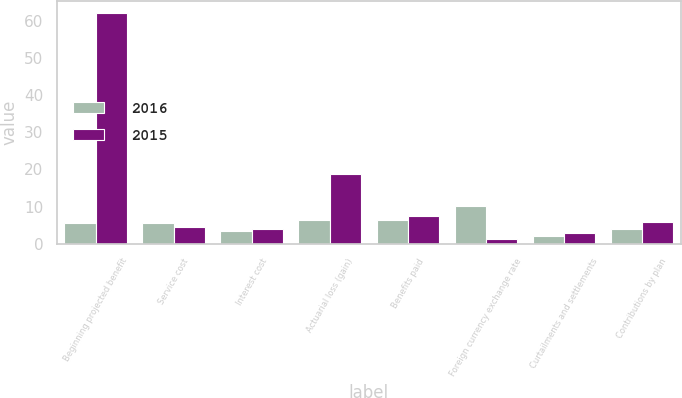Convert chart to OTSL. <chart><loc_0><loc_0><loc_500><loc_500><stacked_bar_chart><ecel><fcel>Beginning projected benefit<fcel>Service cost<fcel>Interest cost<fcel>Actuarial loss (gain)<fcel>Benefits paid<fcel>Foreign currency exchange rate<fcel>Curtailments and settlements<fcel>Contributions by plan<nl><fcel>2016<fcel>5.7<fcel>5.7<fcel>3.3<fcel>6.3<fcel>6.5<fcel>10.1<fcel>2.2<fcel>4<nl><fcel>2015<fcel>62.2<fcel>4.6<fcel>3.9<fcel>18.8<fcel>7.5<fcel>1.2<fcel>2.9<fcel>5.9<nl></chart> 